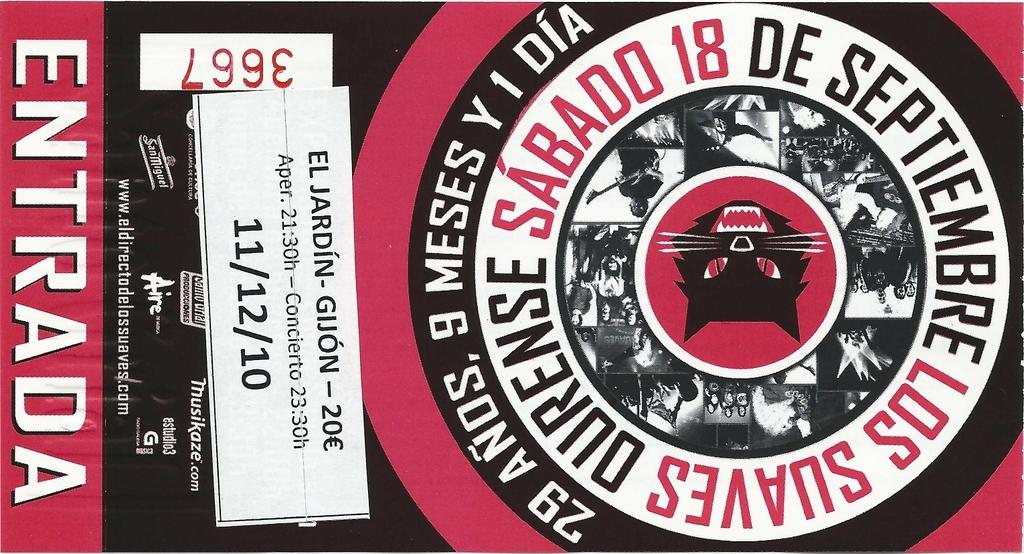Provide a one-sentence caption for the provided image. Ticket for sabado los suaves for november two thousand ten. 